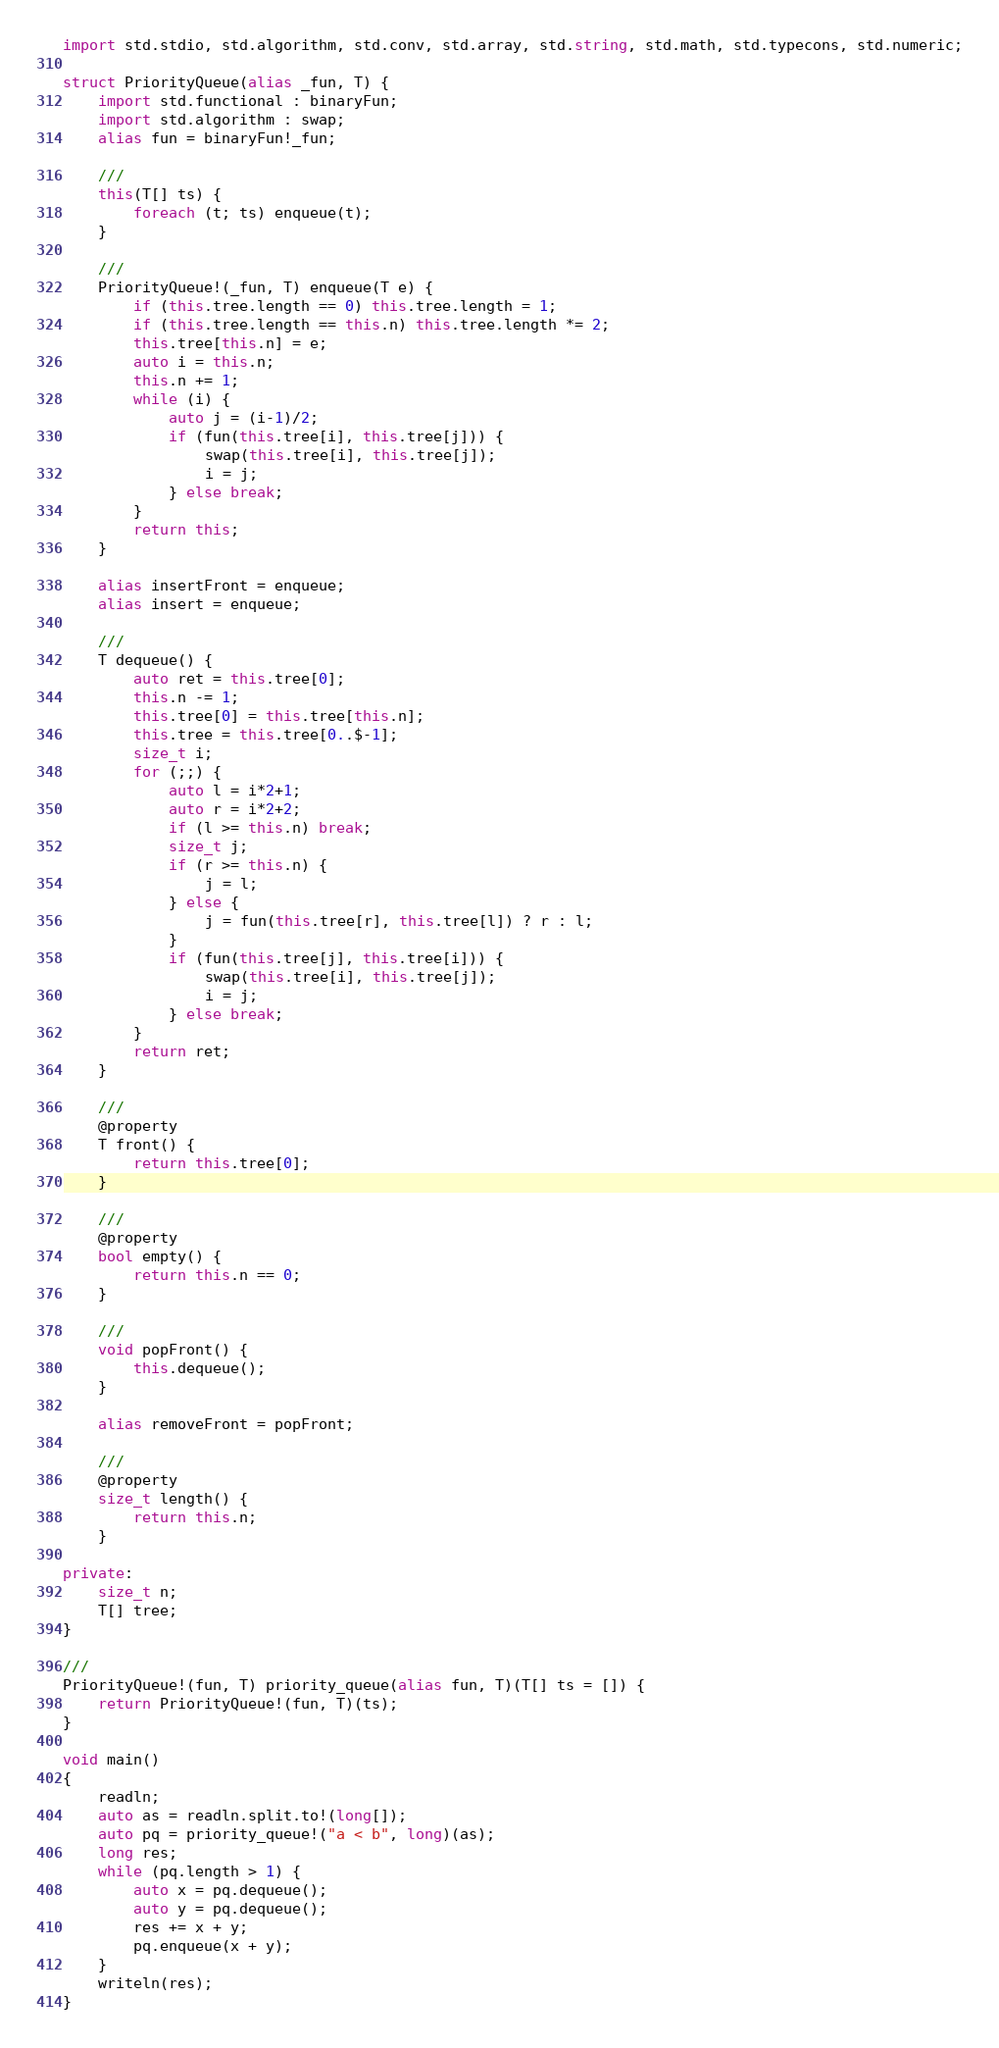<code> <loc_0><loc_0><loc_500><loc_500><_D_>import std.stdio, std.algorithm, std.conv, std.array, std.string, std.math, std.typecons, std.numeric;

struct PriorityQueue(alias _fun, T) {
    import std.functional : binaryFun;
    import std.algorithm : swap;
    alias fun = binaryFun!_fun;

    ///
    this(T[] ts) {
        foreach (t; ts) enqueue(t);
    }

    ///
    PriorityQueue!(_fun, T) enqueue(T e) {
        if (this.tree.length == 0) this.tree.length = 1;
        if (this.tree.length == this.n) this.tree.length *= 2;
        this.tree[this.n] = e;
        auto i = this.n;
        this.n += 1;
        while (i) {
            auto j = (i-1)/2;
            if (fun(this.tree[i], this.tree[j])) {
                swap(this.tree[i], this.tree[j]);
                i = j;
            } else break;
        }
        return this;
    }

    alias insertFront = enqueue;
    alias insert = enqueue;

    ///
    T dequeue() {
        auto ret = this.tree[0];
        this.n -= 1;
        this.tree[0] = this.tree[this.n];
        this.tree = this.tree[0..$-1];
        size_t i;
        for (;;) {
            auto l = i*2+1;
            auto r = i*2+2;
            if (l >= this.n) break;
            size_t j;
            if (r >= this.n) {
                j = l;
            } else {
                j = fun(this.tree[r], this.tree[l]) ? r : l;
            }
            if (fun(this.tree[j], this.tree[i])) {
                swap(this.tree[i], this.tree[j]);
                i = j;
            } else break;
        }
        return ret;
    }

    ///
    @property
    T front() {
        return this.tree[0];
    }

    ///
    @property
    bool empty() {
        return this.n == 0;
    }

    ///
    void popFront() {
        this.dequeue();
    }

    alias removeFront = popFront;

    ///
    @property
    size_t length() {
        return this.n;
    }

private:
    size_t n;
    T[] tree;
}

///
PriorityQueue!(fun, T) priority_queue(alias fun, T)(T[] ts = []) {
    return PriorityQueue!(fun, T)(ts);
}

void main()
{
    readln;
    auto as = readln.split.to!(long[]);
    auto pq = priority_queue!("a < b", long)(as);
    long res;
    while (pq.length > 1) {
        auto x = pq.dequeue();
        auto y = pq.dequeue();
        res += x + y;
        pq.enqueue(x + y);
    }
    writeln(res);
}</code> 